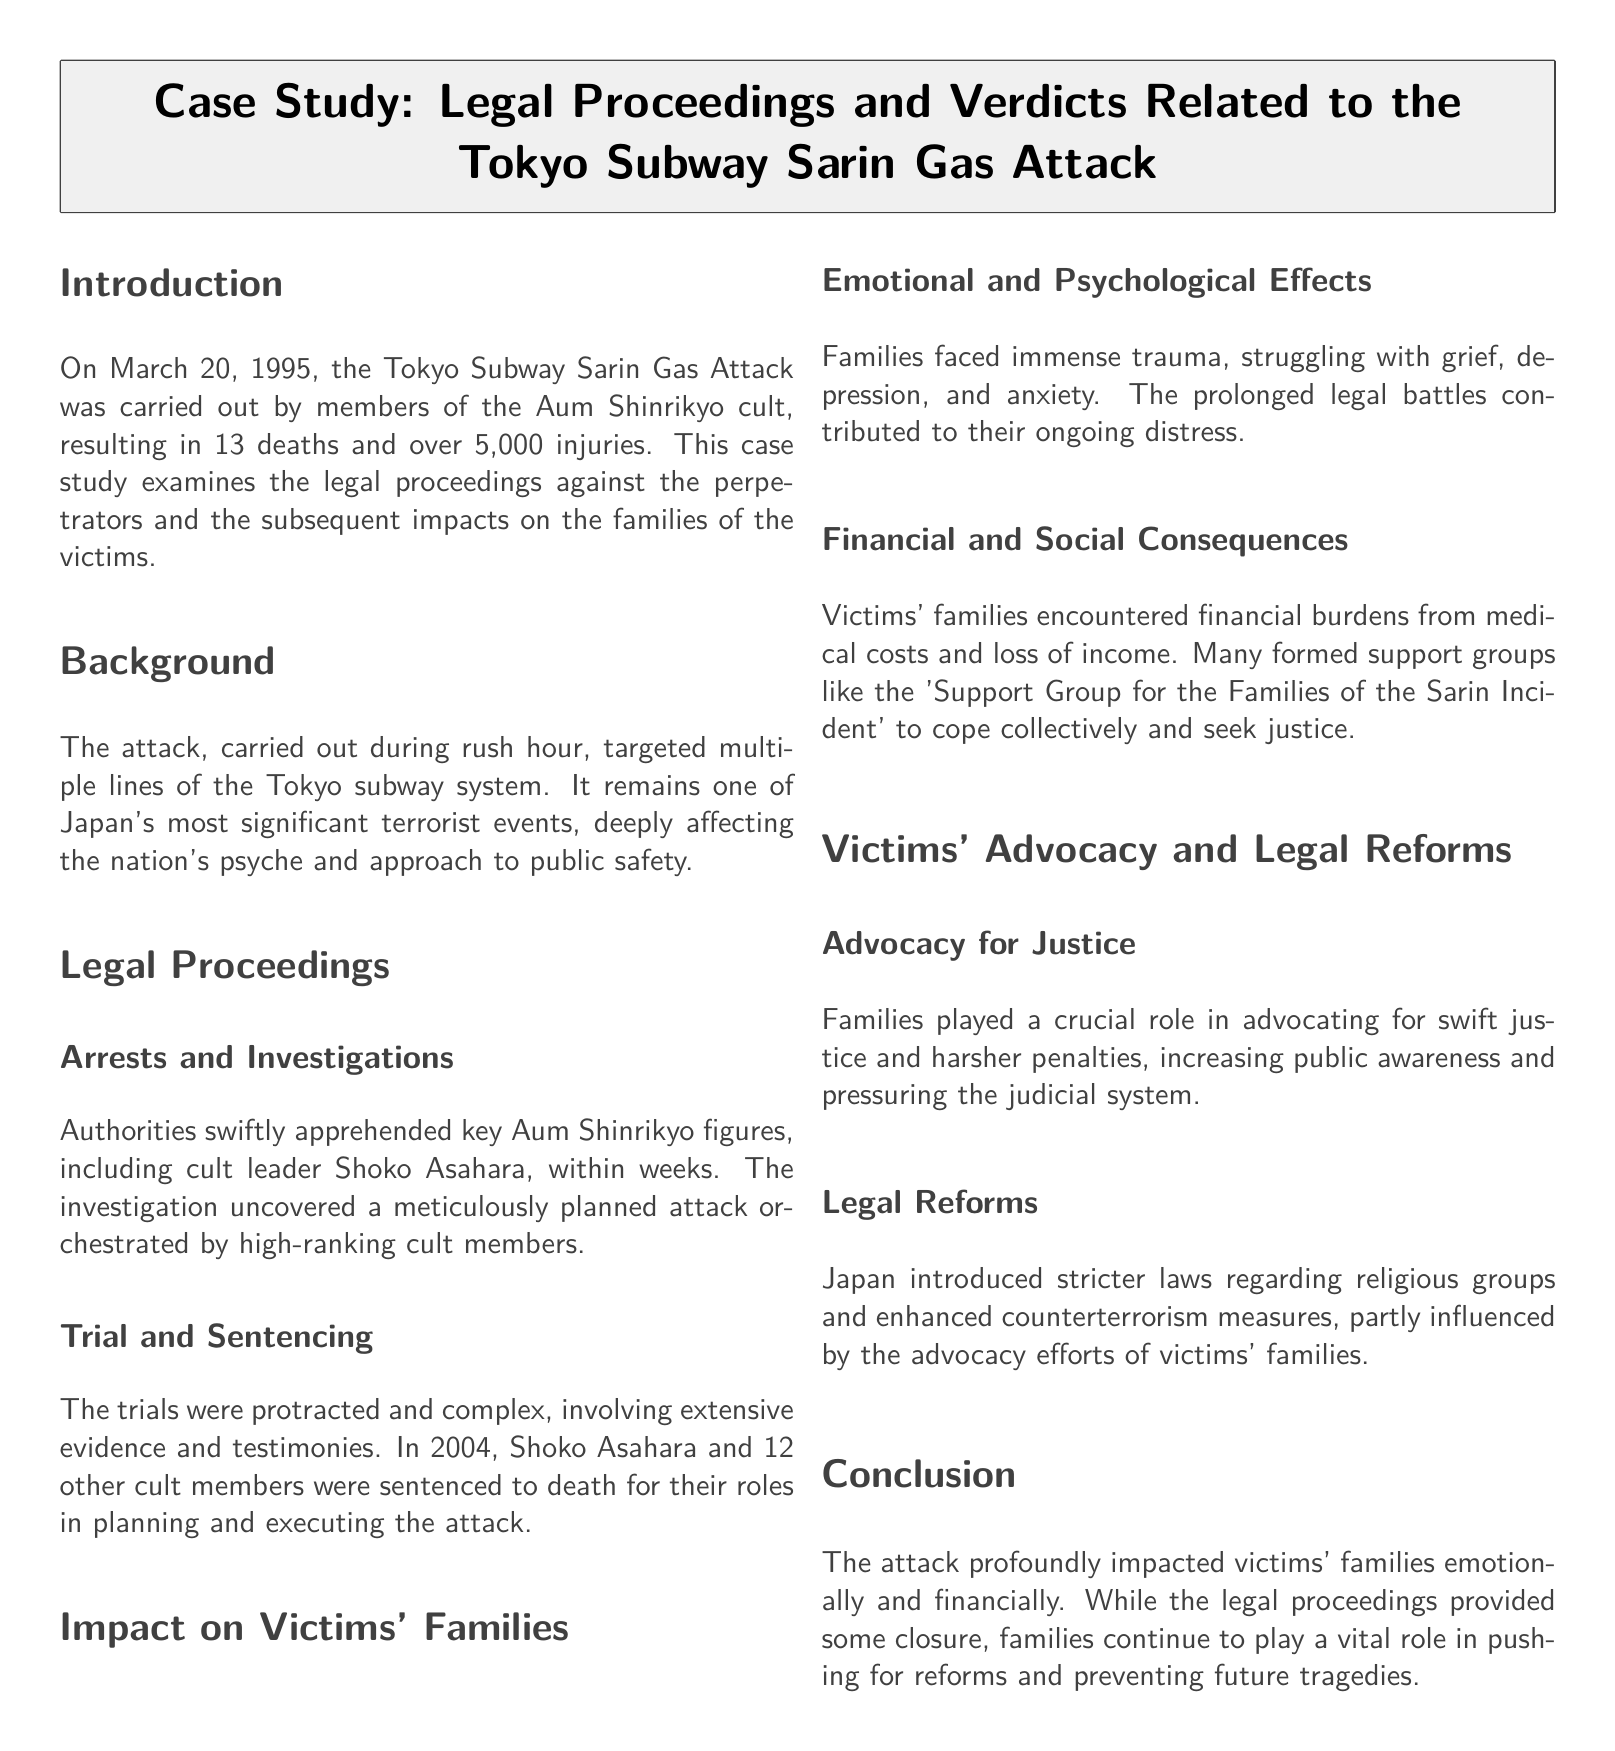What was the date of the Tokyo Subway Sarin Gas Attack? The document states that the attack occurred on March 20, 1995.
Answer: March 20, 1995 How many deaths resulted from the attack? The document mentions that the attack resulted in 13 deaths.
Answer: 13 Who was the leader of Aum Shinrikyo? The document identifies Shoko Asahara as the leader of Aum Shinrikyo.
Answer: Shoko Asahara In what year were Shoko Asahara and other cult members sentenced to death? The document notes that the sentencing occurred in 2004.
Answer: 2004 What significant impact did the prolonged legal battles have on victims' families? According to the document, families struggled with ongoing distress due to the prolonged legal battles.
Answer: Ongoing distress What support group was formed by victims' families? The document states that victims' families formed the 'Support Group for the Families of the Sarin Incident.'
Answer: Support Group for the Families of the Sarin Incident What role did victims' families play in the legal reforms? The document explains that families advocated for swift justice and influenced legal reforms.
Answer: Advocated for justice What kind of laws did Japan introduce following the attack? The document indicates that Japan introduced stricter laws regarding religious groups.
Answer: Stricter laws regarding religious groups 